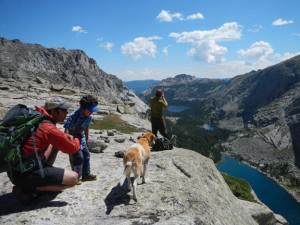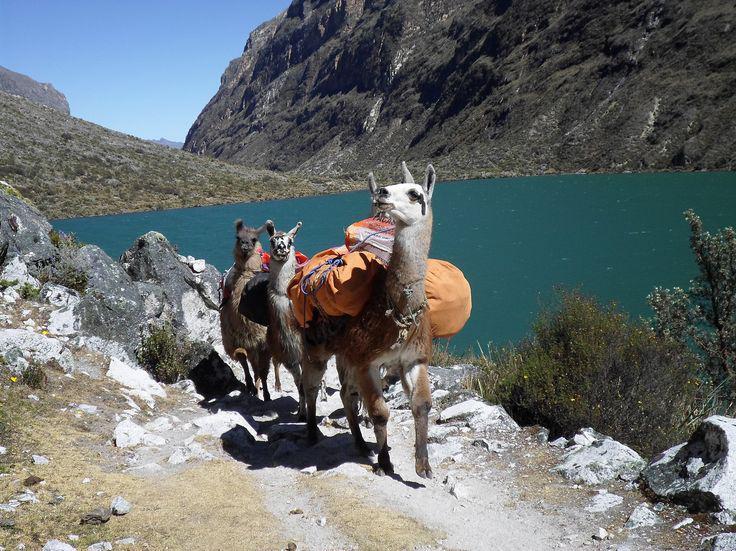The first image is the image on the left, the second image is the image on the right. For the images shown, is this caption "There is a man in camouflage leading a pack of llamas through the snow, the llamas are wearing packs on their backs" true? Answer yes or no. No. The first image is the image on the left, the second image is the image on the right. Examine the images to the left and right. Is the description "The landscape shows a cloudy blue sky on the left image." accurate? Answer yes or no. Yes. 